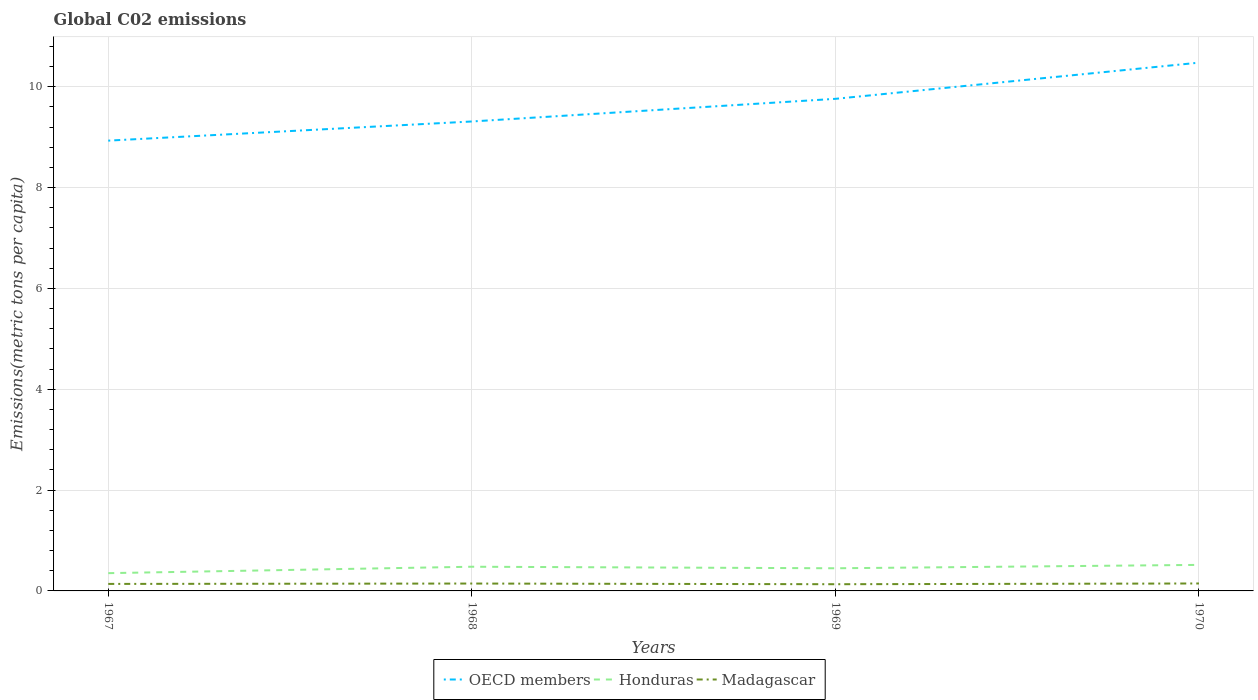Does the line corresponding to OECD members intersect with the line corresponding to Honduras?
Provide a short and direct response. No. Across all years, what is the maximum amount of CO2 emitted in in Honduras?
Your answer should be compact. 0.35. In which year was the amount of CO2 emitted in in Honduras maximum?
Ensure brevity in your answer.  1967. What is the total amount of CO2 emitted in in OECD members in the graph?
Make the answer very short. -0.38. What is the difference between the highest and the second highest amount of CO2 emitted in in Madagascar?
Your answer should be very brief. 0.01. How many lines are there?
Give a very brief answer. 3. Are the values on the major ticks of Y-axis written in scientific E-notation?
Your answer should be compact. No. Where does the legend appear in the graph?
Your response must be concise. Bottom center. How many legend labels are there?
Your answer should be compact. 3. What is the title of the graph?
Offer a very short reply. Global C02 emissions. What is the label or title of the X-axis?
Your answer should be very brief. Years. What is the label or title of the Y-axis?
Offer a very short reply. Emissions(metric tons per capita). What is the Emissions(metric tons per capita) in OECD members in 1967?
Provide a succinct answer. 8.93. What is the Emissions(metric tons per capita) of Honduras in 1967?
Your response must be concise. 0.35. What is the Emissions(metric tons per capita) in Madagascar in 1967?
Make the answer very short. 0.14. What is the Emissions(metric tons per capita) of OECD members in 1968?
Provide a succinct answer. 9.31. What is the Emissions(metric tons per capita) of Honduras in 1968?
Keep it short and to the point. 0.48. What is the Emissions(metric tons per capita) in Madagascar in 1968?
Your answer should be compact. 0.15. What is the Emissions(metric tons per capita) in OECD members in 1969?
Offer a terse response. 9.76. What is the Emissions(metric tons per capita) of Honduras in 1969?
Give a very brief answer. 0.45. What is the Emissions(metric tons per capita) in Madagascar in 1969?
Your answer should be very brief. 0.13. What is the Emissions(metric tons per capita) of OECD members in 1970?
Give a very brief answer. 10.48. What is the Emissions(metric tons per capita) in Honduras in 1970?
Ensure brevity in your answer.  0.52. What is the Emissions(metric tons per capita) in Madagascar in 1970?
Ensure brevity in your answer.  0.15. Across all years, what is the maximum Emissions(metric tons per capita) of OECD members?
Provide a short and direct response. 10.48. Across all years, what is the maximum Emissions(metric tons per capita) in Honduras?
Provide a short and direct response. 0.52. Across all years, what is the maximum Emissions(metric tons per capita) in Madagascar?
Provide a short and direct response. 0.15. Across all years, what is the minimum Emissions(metric tons per capita) in OECD members?
Offer a terse response. 8.93. Across all years, what is the minimum Emissions(metric tons per capita) of Honduras?
Ensure brevity in your answer.  0.35. Across all years, what is the minimum Emissions(metric tons per capita) in Madagascar?
Ensure brevity in your answer.  0.13. What is the total Emissions(metric tons per capita) in OECD members in the graph?
Provide a succinct answer. 38.48. What is the total Emissions(metric tons per capita) in Honduras in the graph?
Keep it short and to the point. 1.8. What is the total Emissions(metric tons per capita) of Madagascar in the graph?
Offer a terse response. 0.57. What is the difference between the Emissions(metric tons per capita) of OECD members in 1967 and that in 1968?
Provide a short and direct response. -0.38. What is the difference between the Emissions(metric tons per capita) of Honduras in 1967 and that in 1968?
Your answer should be very brief. -0.13. What is the difference between the Emissions(metric tons per capita) of Madagascar in 1967 and that in 1968?
Your answer should be compact. -0.01. What is the difference between the Emissions(metric tons per capita) in OECD members in 1967 and that in 1969?
Make the answer very short. -0.83. What is the difference between the Emissions(metric tons per capita) in Honduras in 1967 and that in 1969?
Ensure brevity in your answer.  -0.1. What is the difference between the Emissions(metric tons per capita) in Madagascar in 1967 and that in 1969?
Keep it short and to the point. 0.01. What is the difference between the Emissions(metric tons per capita) of OECD members in 1967 and that in 1970?
Give a very brief answer. -1.55. What is the difference between the Emissions(metric tons per capita) of Honduras in 1967 and that in 1970?
Your response must be concise. -0.16. What is the difference between the Emissions(metric tons per capita) of Madagascar in 1967 and that in 1970?
Provide a short and direct response. -0.01. What is the difference between the Emissions(metric tons per capita) of OECD members in 1968 and that in 1969?
Provide a succinct answer. -0.45. What is the difference between the Emissions(metric tons per capita) in Honduras in 1968 and that in 1969?
Your response must be concise. 0.03. What is the difference between the Emissions(metric tons per capita) of Madagascar in 1968 and that in 1969?
Your response must be concise. 0.01. What is the difference between the Emissions(metric tons per capita) in OECD members in 1968 and that in 1970?
Keep it short and to the point. -1.17. What is the difference between the Emissions(metric tons per capita) in Honduras in 1968 and that in 1970?
Your answer should be compact. -0.04. What is the difference between the Emissions(metric tons per capita) of Madagascar in 1968 and that in 1970?
Make the answer very short. -0. What is the difference between the Emissions(metric tons per capita) in OECD members in 1969 and that in 1970?
Your answer should be very brief. -0.72. What is the difference between the Emissions(metric tons per capita) in Honduras in 1969 and that in 1970?
Your answer should be compact. -0.07. What is the difference between the Emissions(metric tons per capita) of Madagascar in 1969 and that in 1970?
Your answer should be compact. -0.01. What is the difference between the Emissions(metric tons per capita) in OECD members in 1967 and the Emissions(metric tons per capita) in Honduras in 1968?
Your answer should be very brief. 8.45. What is the difference between the Emissions(metric tons per capita) of OECD members in 1967 and the Emissions(metric tons per capita) of Madagascar in 1968?
Provide a succinct answer. 8.79. What is the difference between the Emissions(metric tons per capita) in Honduras in 1967 and the Emissions(metric tons per capita) in Madagascar in 1968?
Provide a short and direct response. 0.21. What is the difference between the Emissions(metric tons per capita) in OECD members in 1967 and the Emissions(metric tons per capita) in Honduras in 1969?
Your response must be concise. 8.48. What is the difference between the Emissions(metric tons per capita) of OECD members in 1967 and the Emissions(metric tons per capita) of Madagascar in 1969?
Offer a terse response. 8.8. What is the difference between the Emissions(metric tons per capita) of Honduras in 1967 and the Emissions(metric tons per capita) of Madagascar in 1969?
Offer a very short reply. 0.22. What is the difference between the Emissions(metric tons per capita) of OECD members in 1967 and the Emissions(metric tons per capita) of Honduras in 1970?
Your response must be concise. 8.42. What is the difference between the Emissions(metric tons per capita) in OECD members in 1967 and the Emissions(metric tons per capita) in Madagascar in 1970?
Ensure brevity in your answer.  8.78. What is the difference between the Emissions(metric tons per capita) of Honduras in 1967 and the Emissions(metric tons per capita) of Madagascar in 1970?
Your answer should be very brief. 0.2. What is the difference between the Emissions(metric tons per capita) in OECD members in 1968 and the Emissions(metric tons per capita) in Honduras in 1969?
Keep it short and to the point. 8.86. What is the difference between the Emissions(metric tons per capita) in OECD members in 1968 and the Emissions(metric tons per capita) in Madagascar in 1969?
Keep it short and to the point. 9.18. What is the difference between the Emissions(metric tons per capita) of Honduras in 1968 and the Emissions(metric tons per capita) of Madagascar in 1969?
Provide a succinct answer. 0.35. What is the difference between the Emissions(metric tons per capita) of OECD members in 1968 and the Emissions(metric tons per capita) of Honduras in 1970?
Your answer should be compact. 8.8. What is the difference between the Emissions(metric tons per capita) of OECD members in 1968 and the Emissions(metric tons per capita) of Madagascar in 1970?
Ensure brevity in your answer.  9.16. What is the difference between the Emissions(metric tons per capita) of Honduras in 1968 and the Emissions(metric tons per capita) of Madagascar in 1970?
Give a very brief answer. 0.33. What is the difference between the Emissions(metric tons per capita) of OECD members in 1969 and the Emissions(metric tons per capita) of Honduras in 1970?
Your response must be concise. 9.24. What is the difference between the Emissions(metric tons per capita) of OECD members in 1969 and the Emissions(metric tons per capita) of Madagascar in 1970?
Keep it short and to the point. 9.61. What is the difference between the Emissions(metric tons per capita) in Honduras in 1969 and the Emissions(metric tons per capita) in Madagascar in 1970?
Your answer should be compact. 0.3. What is the average Emissions(metric tons per capita) in OECD members per year?
Ensure brevity in your answer.  9.62. What is the average Emissions(metric tons per capita) of Honduras per year?
Offer a very short reply. 0.45. What is the average Emissions(metric tons per capita) in Madagascar per year?
Offer a very short reply. 0.14. In the year 1967, what is the difference between the Emissions(metric tons per capita) in OECD members and Emissions(metric tons per capita) in Honduras?
Provide a short and direct response. 8.58. In the year 1967, what is the difference between the Emissions(metric tons per capita) of OECD members and Emissions(metric tons per capita) of Madagascar?
Provide a succinct answer. 8.79. In the year 1967, what is the difference between the Emissions(metric tons per capita) of Honduras and Emissions(metric tons per capita) of Madagascar?
Give a very brief answer. 0.21. In the year 1968, what is the difference between the Emissions(metric tons per capita) in OECD members and Emissions(metric tons per capita) in Honduras?
Give a very brief answer. 8.83. In the year 1968, what is the difference between the Emissions(metric tons per capita) in OECD members and Emissions(metric tons per capita) in Madagascar?
Your answer should be compact. 9.17. In the year 1968, what is the difference between the Emissions(metric tons per capita) of Honduras and Emissions(metric tons per capita) of Madagascar?
Ensure brevity in your answer.  0.33. In the year 1969, what is the difference between the Emissions(metric tons per capita) of OECD members and Emissions(metric tons per capita) of Honduras?
Offer a terse response. 9.31. In the year 1969, what is the difference between the Emissions(metric tons per capita) in OECD members and Emissions(metric tons per capita) in Madagascar?
Make the answer very short. 9.63. In the year 1969, what is the difference between the Emissions(metric tons per capita) of Honduras and Emissions(metric tons per capita) of Madagascar?
Provide a succinct answer. 0.32. In the year 1970, what is the difference between the Emissions(metric tons per capita) of OECD members and Emissions(metric tons per capita) of Honduras?
Ensure brevity in your answer.  9.96. In the year 1970, what is the difference between the Emissions(metric tons per capita) of OECD members and Emissions(metric tons per capita) of Madagascar?
Provide a short and direct response. 10.33. In the year 1970, what is the difference between the Emissions(metric tons per capita) in Honduras and Emissions(metric tons per capita) in Madagascar?
Your response must be concise. 0.37. What is the ratio of the Emissions(metric tons per capita) of OECD members in 1967 to that in 1968?
Your answer should be compact. 0.96. What is the ratio of the Emissions(metric tons per capita) in Honduras in 1967 to that in 1968?
Make the answer very short. 0.73. What is the ratio of the Emissions(metric tons per capita) in Madagascar in 1967 to that in 1968?
Keep it short and to the point. 0.95. What is the ratio of the Emissions(metric tons per capita) in OECD members in 1967 to that in 1969?
Give a very brief answer. 0.92. What is the ratio of the Emissions(metric tons per capita) of Honduras in 1967 to that in 1969?
Ensure brevity in your answer.  0.78. What is the ratio of the Emissions(metric tons per capita) in Madagascar in 1967 to that in 1969?
Offer a very short reply. 1.04. What is the ratio of the Emissions(metric tons per capita) of OECD members in 1967 to that in 1970?
Make the answer very short. 0.85. What is the ratio of the Emissions(metric tons per capita) in Honduras in 1967 to that in 1970?
Ensure brevity in your answer.  0.68. What is the ratio of the Emissions(metric tons per capita) in Madagascar in 1967 to that in 1970?
Keep it short and to the point. 0.94. What is the ratio of the Emissions(metric tons per capita) of OECD members in 1968 to that in 1969?
Provide a succinct answer. 0.95. What is the ratio of the Emissions(metric tons per capita) of Honduras in 1968 to that in 1969?
Keep it short and to the point. 1.07. What is the ratio of the Emissions(metric tons per capita) of Madagascar in 1968 to that in 1969?
Keep it short and to the point. 1.1. What is the ratio of the Emissions(metric tons per capita) in OECD members in 1968 to that in 1970?
Provide a succinct answer. 0.89. What is the ratio of the Emissions(metric tons per capita) of Honduras in 1968 to that in 1970?
Keep it short and to the point. 0.93. What is the ratio of the Emissions(metric tons per capita) in OECD members in 1969 to that in 1970?
Ensure brevity in your answer.  0.93. What is the ratio of the Emissions(metric tons per capita) in Honduras in 1969 to that in 1970?
Make the answer very short. 0.87. What is the ratio of the Emissions(metric tons per capita) in Madagascar in 1969 to that in 1970?
Your answer should be compact. 0.9. What is the difference between the highest and the second highest Emissions(metric tons per capita) of OECD members?
Your response must be concise. 0.72. What is the difference between the highest and the second highest Emissions(metric tons per capita) of Honduras?
Your answer should be compact. 0.04. What is the difference between the highest and the second highest Emissions(metric tons per capita) in Madagascar?
Give a very brief answer. 0. What is the difference between the highest and the lowest Emissions(metric tons per capita) of OECD members?
Provide a succinct answer. 1.55. What is the difference between the highest and the lowest Emissions(metric tons per capita) of Honduras?
Provide a short and direct response. 0.16. What is the difference between the highest and the lowest Emissions(metric tons per capita) in Madagascar?
Your response must be concise. 0.01. 